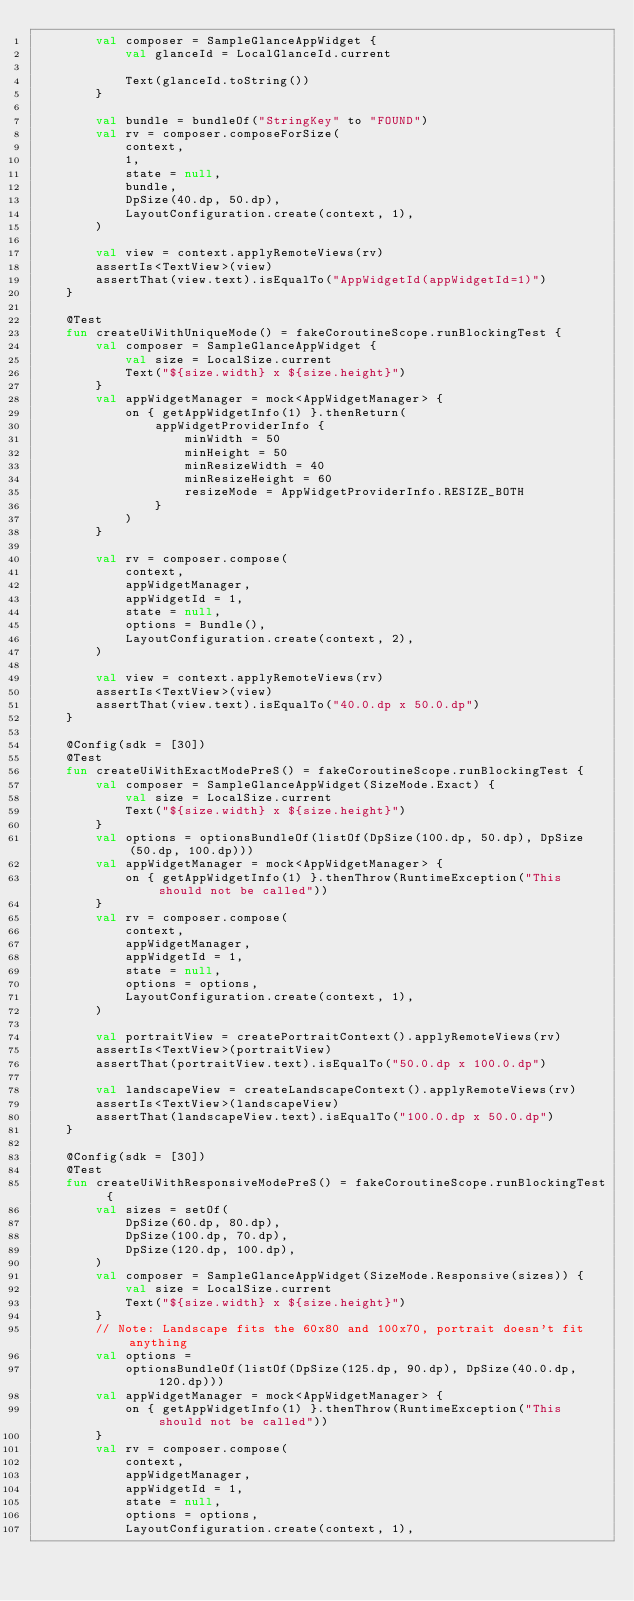<code> <loc_0><loc_0><loc_500><loc_500><_Kotlin_>        val composer = SampleGlanceAppWidget {
            val glanceId = LocalGlanceId.current

            Text(glanceId.toString())
        }

        val bundle = bundleOf("StringKey" to "FOUND")
        val rv = composer.composeForSize(
            context,
            1,
            state = null,
            bundle,
            DpSize(40.dp, 50.dp),
            LayoutConfiguration.create(context, 1),
        )

        val view = context.applyRemoteViews(rv)
        assertIs<TextView>(view)
        assertThat(view.text).isEqualTo("AppWidgetId(appWidgetId=1)")
    }

    @Test
    fun createUiWithUniqueMode() = fakeCoroutineScope.runBlockingTest {
        val composer = SampleGlanceAppWidget {
            val size = LocalSize.current
            Text("${size.width} x ${size.height}")
        }
        val appWidgetManager = mock<AppWidgetManager> {
            on { getAppWidgetInfo(1) }.thenReturn(
                appWidgetProviderInfo {
                    minWidth = 50
                    minHeight = 50
                    minResizeWidth = 40
                    minResizeHeight = 60
                    resizeMode = AppWidgetProviderInfo.RESIZE_BOTH
                }
            )
        }

        val rv = composer.compose(
            context,
            appWidgetManager,
            appWidgetId = 1,
            state = null,
            options = Bundle(),
            LayoutConfiguration.create(context, 2),
        )

        val view = context.applyRemoteViews(rv)
        assertIs<TextView>(view)
        assertThat(view.text).isEqualTo("40.0.dp x 50.0.dp")
    }

    @Config(sdk = [30])
    @Test
    fun createUiWithExactModePreS() = fakeCoroutineScope.runBlockingTest {
        val composer = SampleGlanceAppWidget(SizeMode.Exact) {
            val size = LocalSize.current
            Text("${size.width} x ${size.height}")
        }
        val options = optionsBundleOf(listOf(DpSize(100.dp, 50.dp), DpSize(50.dp, 100.dp)))
        val appWidgetManager = mock<AppWidgetManager> {
            on { getAppWidgetInfo(1) }.thenThrow(RuntimeException("This should not be called"))
        }
        val rv = composer.compose(
            context,
            appWidgetManager,
            appWidgetId = 1,
            state = null,
            options = options,
            LayoutConfiguration.create(context, 1),
        )

        val portraitView = createPortraitContext().applyRemoteViews(rv)
        assertIs<TextView>(portraitView)
        assertThat(portraitView.text).isEqualTo("50.0.dp x 100.0.dp")

        val landscapeView = createLandscapeContext().applyRemoteViews(rv)
        assertIs<TextView>(landscapeView)
        assertThat(landscapeView.text).isEqualTo("100.0.dp x 50.0.dp")
    }

    @Config(sdk = [30])
    @Test
    fun createUiWithResponsiveModePreS() = fakeCoroutineScope.runBlockingTest {
        val sizes = setOf(
            DpSize(60.dp, 80.dp),
            DpSize(100.dp, 70.dp),
            DpSize(120.dp, 100.dp),
        )
        val composer = SampleGlanceAppWidget(SizeMode.Responsive(sizes)) {
            val size = LocalSize.current
            Text("${size.width} x ${size.height}")
        }
        // Note: Landscape fits the 60x80 and 100x70, portrait doesn't fit anything
        val options =
            optionsBundleOf(listOf(DpSize(125.dp, 90.dp), DpSize(40.0.dp, 120.dp)))
        val appWidgetManager = mock<AppWidgetManager> {
            on { getAppWidgetInfo(1) }.thenThrow(RuntimeException("This should not be called"))
        }
        val rv = composer.compose(
            context,
            appWidgetManager,
            appWidgetId = 1,
            state = null,
            options = options,
            LayoutConfiguration.create(context, 1),</code> 